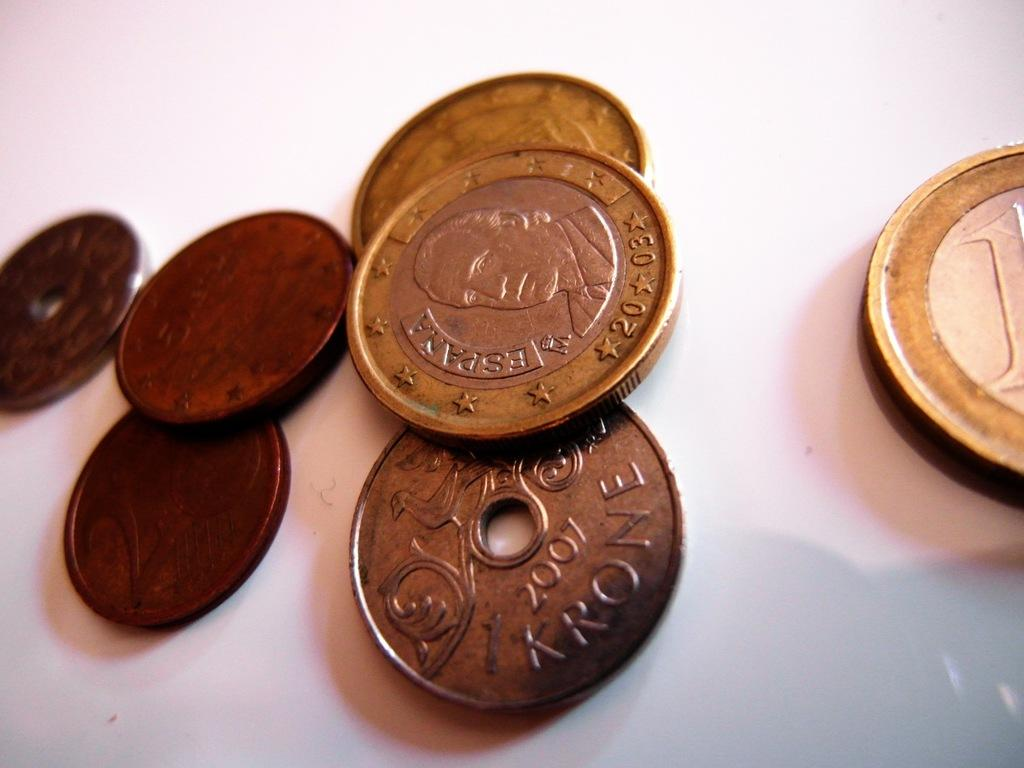<image>
Present a compact description of the photo's key features. old copper colored coins reading KRONE are on a table 